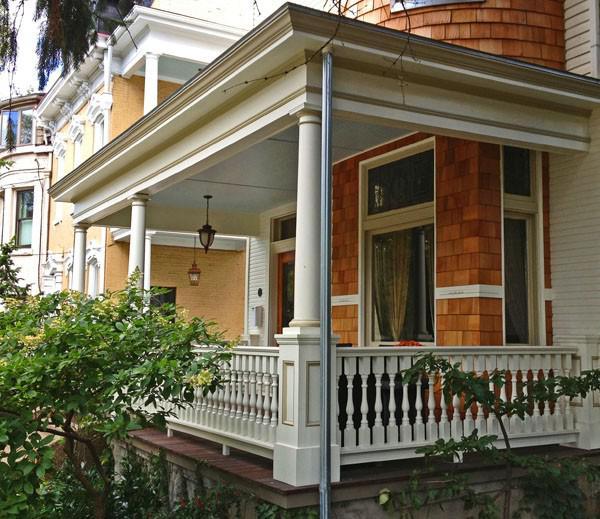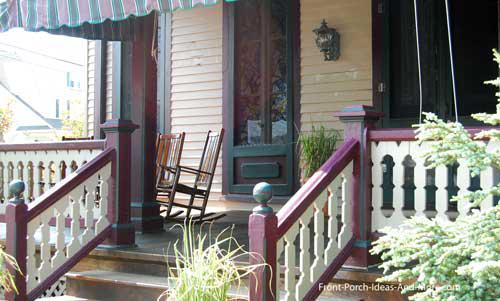The first image is the image on the left, the second image is the image on the right. Evaluate the accuracy of this statement regarding the images: "there is a decorative porch rail on the front porch, with the outside of the home visible and windows". Is it true? Answer yes or no. Yes. 